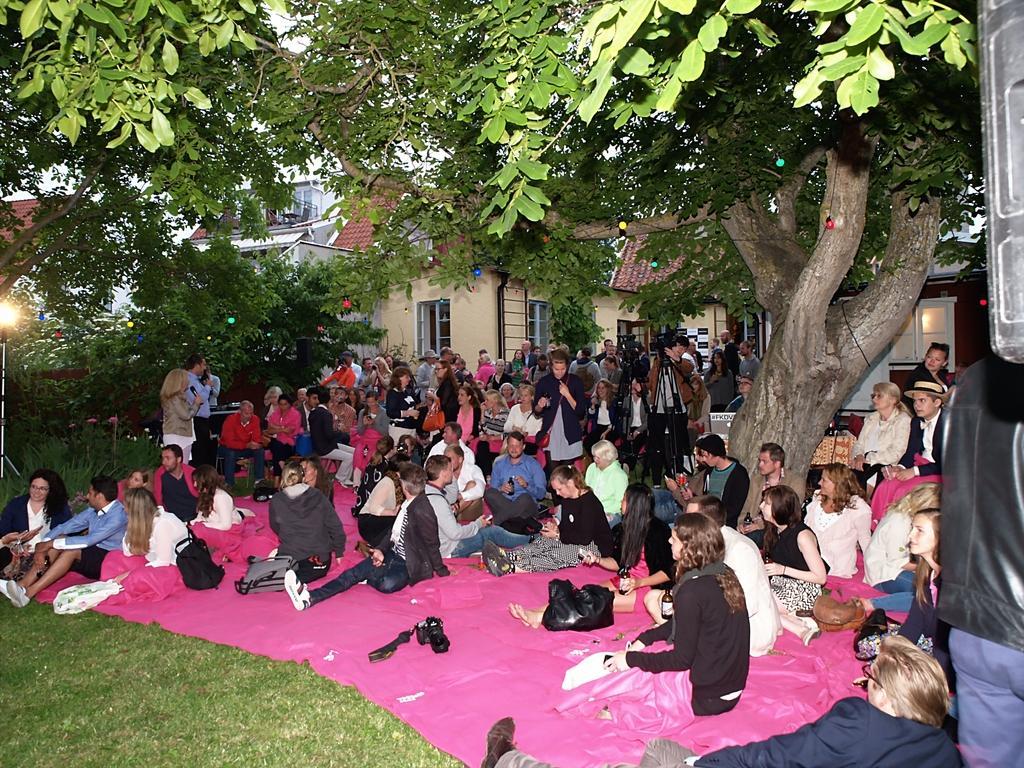Could you give a brief overview of what you see in this image? In this image we can see people sitting in the garden and we can also see trees, camera stand and houses. 